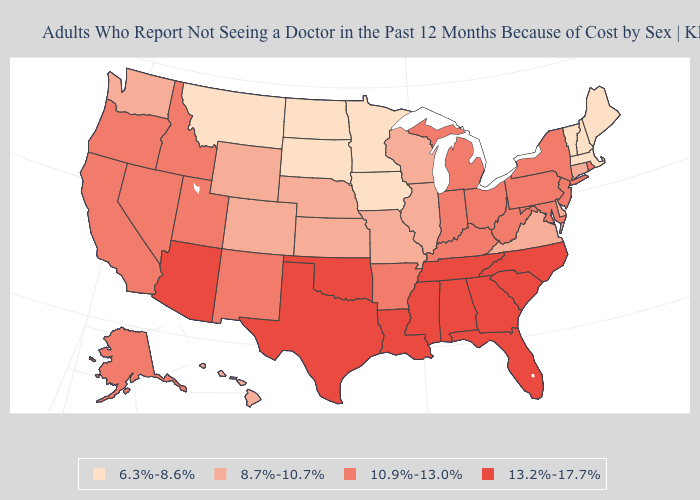Which states hav the highest value in the West?
Keep it brief. Arizona. Name the states that have a value in the range 8.7%-10.7%?
Answer briefly. Colorado, Connecticut, Delaware, Hawaii, Illinois, Kansas, Missouri, Nebraska, Virginia, Washington, Wisconsin, Wyoming. What is the highest value in states that border South Dakota?
Give a very brief answer. 8.7%-10.7%. Name the states that have a value in the range 6.3%-8.6%?
Answer briefly. Iowa, Maine, Massachusetts, Minnesota, Montana, New Hampshire, North Dakota, South Dakota, Vermont. What is the value of Kentucky?
Be succinct. 10.9%-13.0%. Does Maryland have the highest value in the South?
Be succinct. No. How many symbols are there in the legend?
Short answer required. 4. Name the states that have a value in the range 8.7%-10.7%?
Concise answer only. Colorado, Connecticut, Delaware, Hawaii, Illinois, Kansas, Missouri, Nebraska, Virginia, Washington, Wisconsin, Wyoming. Does Colorado have the lowest value in the USA?
Answer briefly. No. Does the map have missing data?
Answer briefly. No. Among the states that border Montana , does South Dakota have the lowest value?
Be succinct. Yes. What is the lowest value in the MidWest?
Answer briefly. 6.3%-8.6%. Does Ohio have the lowest value in the USA?
Write a very short answer. No. Name the states that have a value in the range 10.9%-13.0%?
Be succinct. Alaska, Arkansas, California, Idaho, Indiana, Kentucky, Maryland, Michigan, Nevada, New Jersey, New Mexico, New York, Ohio, Oregon, Pennsylvania, Rhode Island, Utah, West Virginia. 